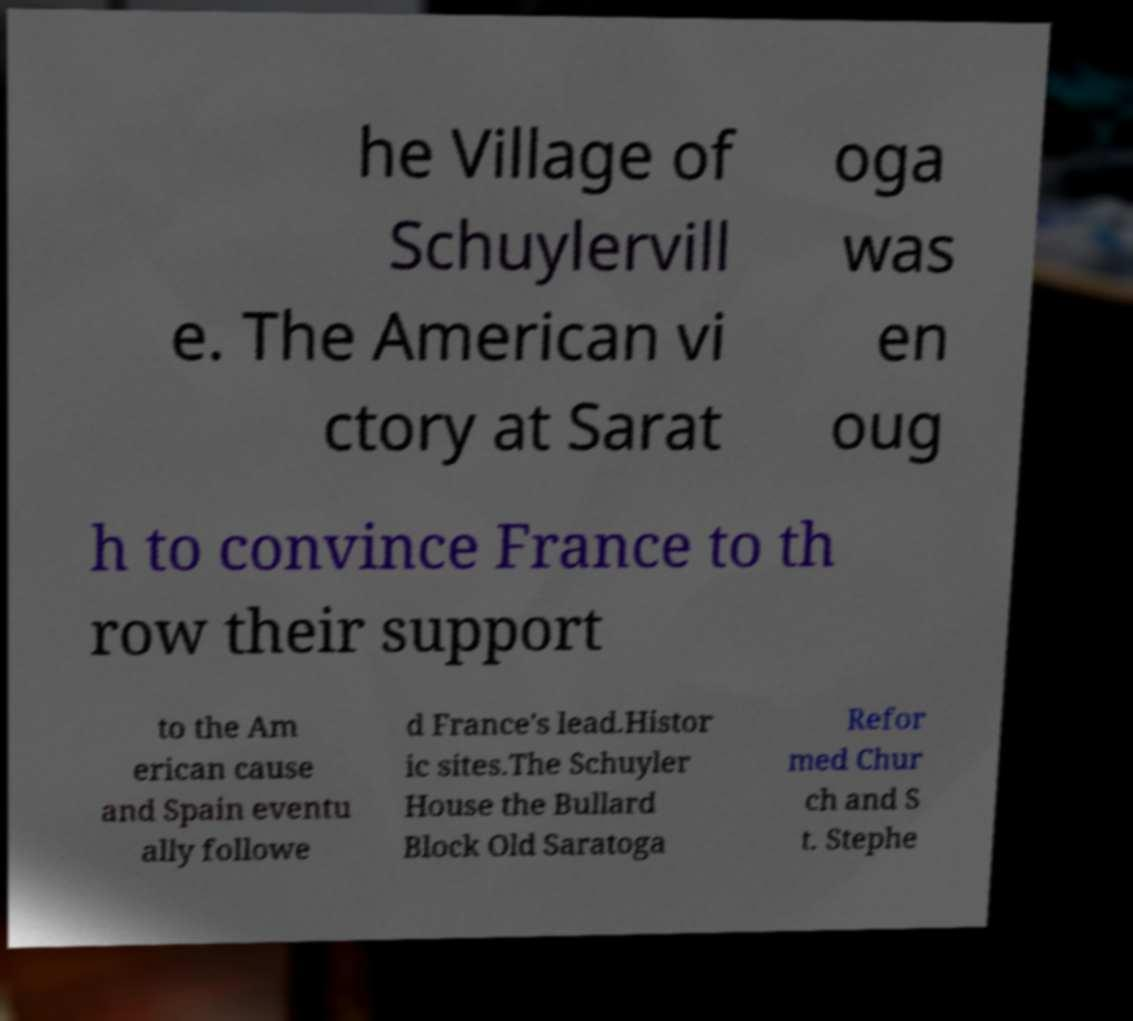Can you read and provide the text displayed in the image?This photo seems to have some interesting text. Can you extract and type it out for me? he Village of Schuylervill e. The American vi ctory at Sarat oga was en oug h to convince France to th row their support to the Am erican cause and Spain eventu ally followe d France's lead.Histor ic sites.The Schuyler House the Bullard Block Old Saratoga Refor med Chur ch and S t. Stephe 